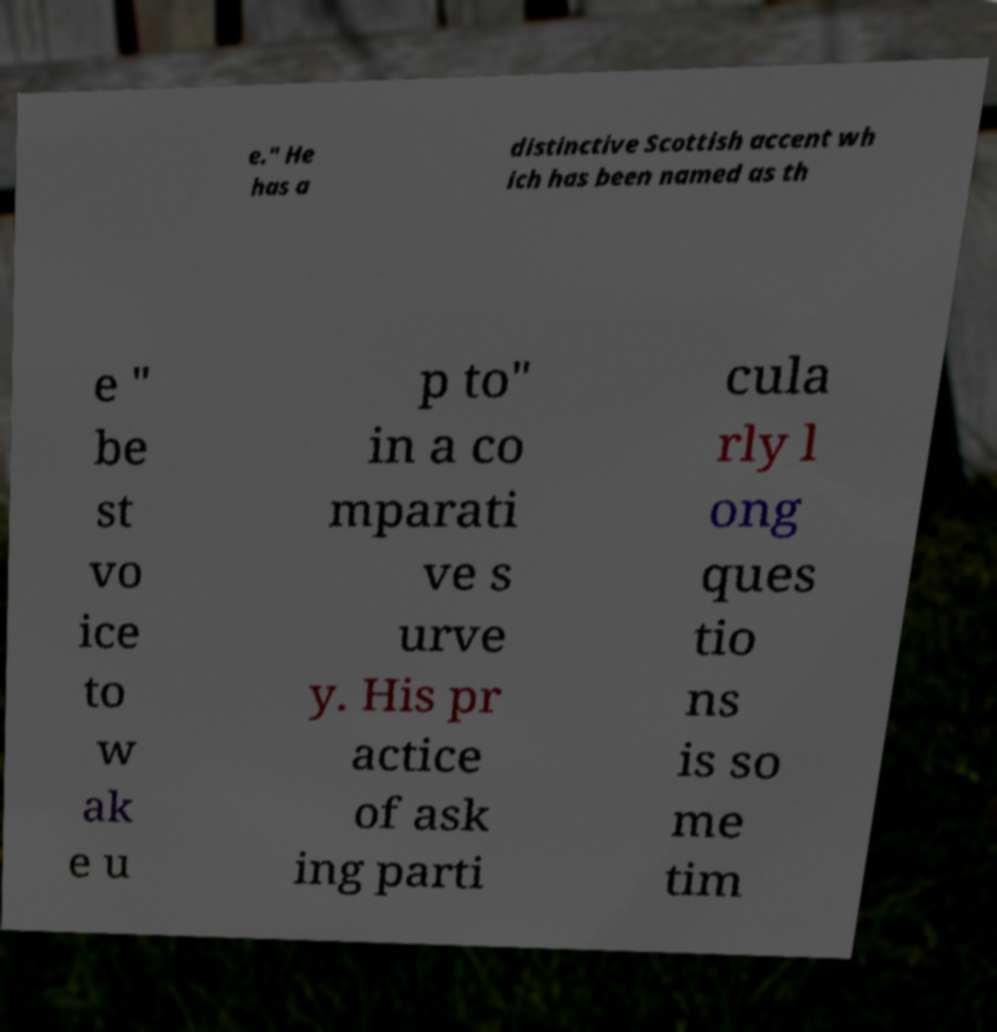Could you assist in decoding the text presented in this image and type it out clearly? e." He has a distinctive Scottish accent wh ich has been named as th e " be st vo ice to w ak e u p to" in a co mparati ve s urve y. His pr actice of ask ing parti cula rly l ong ques tio ns is so me tim 